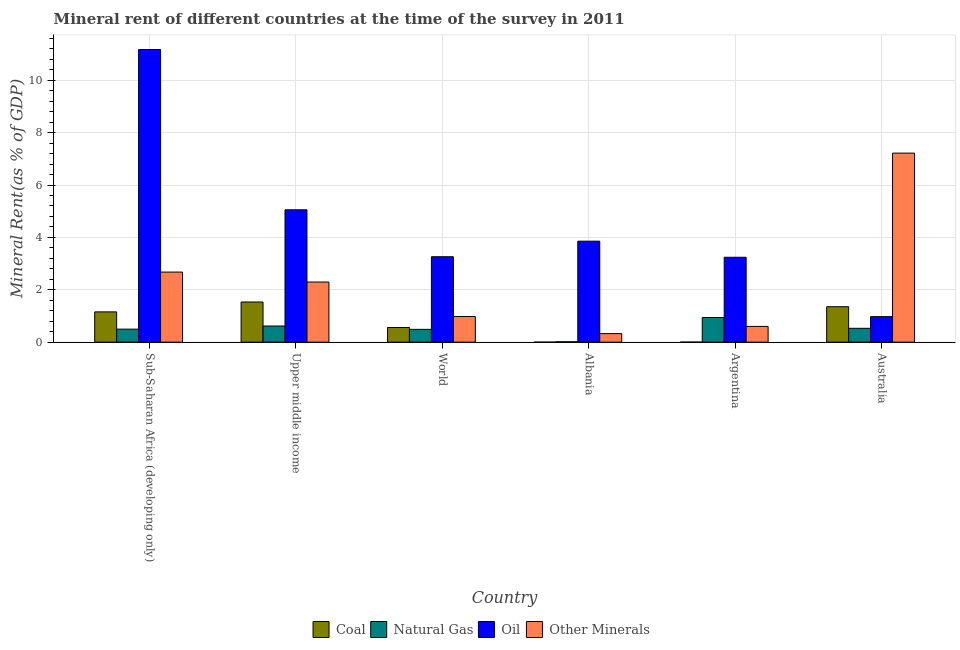How many different coloured bars are there?
Your answer should be compact. 4. Are the number of bars per tick equal to the number of legend labels?
Make the answer very short. Yes. How many bars are there on the 2nd tick from the left?
Provide a succinct answer. 4. What is the label of the 4th group of bars from the left?
Your answer should be compact. Albania. In how many cases, is the number of bars for a given country not equal to the number of legend labels?
Your answer should be compact. 0. What is the coal rent in Sub-Saharan Africa (developing only)?
Keep it short and to the point. 1.16. Across all countries, what is the maximum oil rent?
Make the answer very short. 11.17. Across all countries, what is the minimum natural gas rent?
Keep it short and to the point. 0.01. In which country was the coal rent maximum?
Offer a very short reply. Upper middle income. What is the total coal rent in the graph?
Your answer should be very brief. 4.6. What is the difference between the  rent of other minerals in Albania and that in World?
Make the answer very short. -0.65. What is the difference between the oil rent in Albania and the natural gas rent in World?
Your answer should be very brief. 3.37. What is the average oil rent per country?
Give a very brief answer. 4.59. What is the difference between the coal rent and  rent of other minerals in World?
Provide a succinct answer. -0.42. In how many countries, is the  rent of other minerals greater than 1.6 %?
Provide a succinct answer. 3. What is the ratio of the  rent of other minerals in Argentina to that in World?
Make the answer very short. 0.61. Is the difference between the natural gas rent in Australia and World greater than the difference between the oil rent in Australia and World?
Keep it short and to the point. Yes. What is the difference between the highest and the second highest natural gas rent?
Your answer should be compact. 0.33. What is the difference between the highest and the lowest  rent of other minerals?
Offer a very short reply. 6.89. In how many countries, is the coal rent greater than the average coal rent taken over all countries?
Provide a short and direct response. 3. Is the sum of the coal rent in Argentina and Upper middle income greater than the maximum oil rent across all countries?
Make the answer very short. No. What does the 1st bar from the left in Upper middle income represents?
Keep it short and to the point. Coal. What does the 3rd bar from the right in Upper middle income represents?
Your answer should be very brief. Natural Gas. Is it the case that in every country, the sum of the coal rent and natural gas rent is greater than the oil rent?
Your answer should be very brief. No. How many bars are there?
Provide a succinct answer. 24. Are all the bars in the graph horizontal?
Your answer should be compact. No. What is the difference between two consecutive major ticks on the Y-axis?
Give a very brief answer. 2. Does the graph contain any zero values?
Offer a terse response. No. Where does the legend appear in the graph?
Provide a succinct answer. Bottom center. What is the title of the graph?
Provide a short and direct response. Mineral rent of different countries at the time of the survey in 2011. Does "Industry" appear as one of the legend labels in the graph?
Your response must be concise. No. What is the label or title of the Y-axis?
Provide a short and direct response. Mineral Rent(as % of GDP). What is the Mineral Rent(as % of GDP) of Coal in Sub-Saharan Africa (developing only)?
Give a very brief answer. 1.16. What is the Mineral Rent(as % of GDP) of Natural Gas in Sub-Saharan Africa (developing only)?
Ensure brevity in your answer.  0.5. What is the Mineral Rent(as % of GDP) in Oil in Sub-Saharan Africa (developing only)?
Give a very brief answer. 11.17. What is the Mineral Rent(as % of GDP) of Other Minerals in Sub-Saharan Africa (developing only)?
Your response must be concise. 2.68. What is the Mineral Rent(as % of GDP) of Coal in Upper middle income?
Offer a very short reply. 1.53. What is the Mineral Rent(as % of GDP) in Natural Gas in Upper middle income?
Your response must be concise. 0.62. What is the Mineral Rent(as % of GDP) in Oil in Upper middle income?
Ensure brevity in your answer.  5.05. What is the Mineral Rent(as % of GDP) of Other Minerals in Upper middle income?
Keep it short and to the point. 2.3. What is the Mineral Rent(as % of GDP) of Coal in World?
Your response must be concise. 0.56. What is the Mineral Rent(as % of GDP) of Natural Gas in World?
Keep it short and to the point. 0.49. What is the Mineral Rent(as % of GDP) in Oil in World?
Provide a short and direct response. 3.26. What is the Mineral Rent(as % of GDP) in Other Minerals in World?
Keep it short and to the point. 0.98. What is the Mineral Rent(as % of GDP) of Coal in Albania?
Make the answer very short. 0. What is the Mineral Rent(as % of GDP) of Natural Gas in Albania?
Ensure brevity in your answer.  0.01. What is the Mineral Rent(as % of GDP) in Oil in Albania?
Provide a succinct answer. 3.86. What is the Mineral Rent(as % of GDP) in Other Minerals in Albania?
Give a very brief answer. 0.33. What is the Mineral Rent(as % of GDP) of Coal in Argentina?
Provide a succinct answer. 0. What is the Mineral Rent(as % of GDP) of Natural Gas in Argentina?
Offer a terse response. 0.94. What is the Mineral Rent(as % of GDP) of Oil in Argentina?
Make the answer very short. 3.24. What is the Mineral Rent(as % of GDP) in Other Minerals in Argentina?
Provide a short and direct response. 0.6. What is the Mineral Rent(as % of GDP) of Coal in Australia?
Ensure brevity in your answer.  1.35. What is the Mineral Rent(as % of GDP) in Natural Gas in Australia?
Offer a very short reply. 0.53. What is the Mineral Rent(as % of GDP) in Oil in Australia?
Provide a succinct answer. 0.97. What is the Mineral Rent(as % of GDP) of Other Minerals in Australia?
Your answer should be very brief. 7.22. Across all countries, what is the maximum Mineral Rent(as % of GDP) of Coal?
Make the answer very short. 1.53. Across all countries, what is the maximum Mineral Rent(as % of GDP) in Natural Gas?
Provide a short and direct response. 0.94. Across all countries, what is the maximum Mineral Rent(as % of GDP) in Oil?
Your answer should be very brief. 11.17. Across all countries, what is the maximum Mineral Rent(as % of GDP) of Other Minerals?
Give a very brief answer. 7.22. Across all countries, what is the minimum Mineral Rent(as % of GDP) of Coal?
Your response must be concise. 0. Across all countries, what is the minimum Mineral Rent(as % of GDP) of Natural Gas?
Make the answer very short. 0.01. Across all countries, what is the minimum Mineral Rent(as % of GDP) in Oil?
Ensure brevity in your answer.  0.97. Across all countries, what is the minimum Mineral Rent(as % of GDP) of Other Minerals?
Provide a short and direct response. 0.33. What is the total Mineral Rent(as % of GDP) in Coal in the graph?
Ensure brevity in your answer.  4.6. What is the total Mineral Rent(as % of GDP) in Natural Gas in the graph?
Your response must be concise. 3.09. What is the total Mineral Rent(as % of GDP) in Oil in the graph?
Offer a very short reply. 27.56. What is the total Mineral Rent(as % of GDP) of Other Minerals in the graph?
Provide a short and direct response. 14.09. What is the difference between the Mineral Rent(as % of GDP) of Coal in Sub-Saharan Africa (developing only) and that in Upper middle income?
Keep it short and to the point. -0.38. What is the difference between the Mineral Rent(as % of GDP) in Natural Gas in Sub-Saharan Africa (developing only) and that in Upper middle income?
Your response must be concise. -0.12. What is the difference between the Mineral Rent(as % of GDP) of Oil in Sub-Saharan Africa (developing only) and that in Upper middle income?
Provide a succinct answer. 6.12. What is the difference between the Mineral Rent(as % of GDP) of Other Minerals in Sub-Saharan Africa (developing only) and that in Upper middle income?
Provide a succinct answer. 0.38. What is the difference between the Mineral Rent(as % of GDP) of Coal in Sub-Saharan Africa (developing only) and that in World?
Your answer should be very brief. 0.6. What is the difference between the Mineral Rent(as % of GDP) in Natural Gas in Sub-Saharan Africa (developing only) and that in World?
Provide a succinct answer. 0.01. What is the difference between the Mineral Rent(as % of GDP) of Oil in Sub-Saharan Africa (developing only) and that in World?
Ensure brevity in your answer.  7.91. What is the difference between the Mineral Rent(as % of GDP) in Other Minerals in Sub-Saharan Africa (developing only) and that in World?
Provide a short and direct response. 1.7. What is the difference between the Mineral Rent(as % of GDP) of Coal in Sub-Saharan Africa (developing only) and that in Albania?
Your answer should be very brief. 1.16. What is the difference between the Mineral Rent(as % of GDP) in Natural Gas in Sub-Saharan Africa (developing only) and that in Albania?
Your response must be concise. 0.48. What is the difference between the Mineral Rent(as % of GDP) in Oil in Sub-Saharan Africa (developing only) and that in Albania?
Make the answer very short. 7.32. What is the difference between the Mineral Rent(as % of GDP) in Other Minerals in Sub-Saharan Africa (developing only) and that in Albania?
Provide a succinct answer. 2.35. What is the difference between the Mineral Rent(as % of GDP) of Coal in Sub-Saharan Africa (developing only) and that in Argentina?
Ensure brevity in your answer.  1.15. What is the difference between the Mineral Rent(as % of GDP) of Natural Gas in Sub-Saharan Africa (developing only) and that in Argentina?
Give a very brief answer. -0.44. What is the difference between the Mineral Rent(as % of GDP) in Oil in Sub-Saharan Africa (developing only) and that in Argentina?
Give a very brief answer. 7.93. What is the difference between the Mineral Rent(as % of GDP) of Other Minerals in Sub-Saharan Africa (developing only) and that in Argentina?
Provide a succinct answer. 2.07. What is the difference between the Mineral Rent(as % of GDP) in Coal in Sub-Saharan Africa (developing only) and that in Australia?
Keep it short and to the point. -0.2. What is the difference between the Mineral Rent(as % of GDP) in Natural Gas in Sub-Saharan Africa (developing only) and that in Australia?
Your answer should be compact. -0.03. What is the difference between the Mineral Rent(as % of GDP) of Oil in Sub-Saharan Africa (developing only) and that in Australia?
Provide a succinct answer. 10.2. What is the difference between the Mineral Rent(as % of GDP) in Other Minerals in Sub-Saharan Africa (developing only) and that in Australia?
Keep it short and to the point. -4.54. What is the difference between the Mineral Rent(as % of GDP) of Coal in Upper middle income and that in World?
Your response must be concise. 0.97. What is the difference between the Mineral Rent(as % of GDP) in Natural Gas in Upper middle income and that in World?
Your response must be concise. 0.13. What is the difference between the Mineral Rent(as % of GDP) in Oil in Upper middle income and that in World?
Provide a succinct answer. 1.79. What is the difference between the Mineral Rent(as % of GDP) of Other Minerals in Upper middle income and that in World?
Your answer should be compact. 1.32. What is the difference between the Mineral Rent(as % of GDP) of Coal in Upper middle income and that in Albania?
Your response must be concise. 1.53. What is the difference between the Mineral Rent(as % of GDP) in Natural Gas in Upper middle income and that in Albania?
Your answer should be compact. 0.6. What is the difference between the Mineral Rent(as % of GDP) of Oil in Upper middle income and that in Albania?
Offer a terse response. 1.2. What is the difference between the Mineral Rent(as % of GDP) in Other Minerals in Upper middle income and that in Albania?
Offer a very short reply. 1.97. What is the difference between the Mineral Rent(as % of GDP) in Coal in Upper middle income and that in Argentina?
Your answer should be very brief. 1.53. What is the difference between the Mineral Rent(as % of GDP) of Natural Gas in Upper middle income and that in Argentina?
Ensure brevity in your answer.  -0.33. What is the difference between the Mineral Rent(as % of GDP) in Oil in Upper middle income and that in Argentina?
Give a very brief answer. 1.81. What is the difference between the Mineral Rent(as % of GDP) of Other Minerals in Upper middle income and that in Argentina?
Your answer should be very brief. 1.69. What is the difference between the Mineral Rent(as % of GDP) of Coal in Upper middle income and that in Australia?
Offer a terse response. 0.18. What is the difference between the Mineral Rent(as % of GDP) of Natural Gas in Upper middle income and that in Australia?
Your answer should be compact. 0.09. What is the difference between the Mineral Rent(as % of GDP) in Oil in Upper middle income and that in Australia?
Give a very brief answer. 4.08. What is the difference between the Mineral Rent(as % of GDP) of Other Minerals in Upper middle income and that in Australia?
Offer a very short reply. -4.92. What is the difference between the Mineral Rent(as % of GDP) of Coal in World and that in Albania?
Provide a succinct answer. 0.56. What is the difference between the Mineral Rent(as % of GDP) in Natural Gas in World and that in Albania?
Keep it short and to the point. 0.47. What is the difference between the Mineral Rent(as % of GDP) of Oil in World and that in Albania?
Provide a succinct answer. -0.59. What is the difference between the Mineral Rent(as % of GDP) of Other Minerals in World and that in Albania?
Your answer should be very brief. 0.65. What is the difference between the Mineral Rent(as % of GDP) of Coal in World and that in Argentina?
Your response must be concise. 0.56. What is the difference between the Mineral Rent(as % of GDP) of Natural Gas in World and that in Argentina?
Offer a very short reply. -0.45. What is the difference between the Mineral Rent(as % of GDP) in Oil in World and that in Argentina?
Ensure brevity in your answer.  0.02. What is the difference between the Mineral Rent(as % of GDP) of Other Minerals in World and that in Argentina?
Provide a succinct answer. 0.38. What is the difference between the Mineral Rent(as % of GDP) of Coal in World and that in Australia?
Keep it short and to the point. -0.79. What is the difference between the Mineral Rent(as % of GDP) in Natural Gas in World and that in Australia?
Ensure brevity in your answer.  -0.04. What is the difference between the Mineral Rent(as % of GDP) of Oil in World and that in Australia?
Provide a short and direct response. 2.29. What is the difference between the Mineral Rent(as % of GDP) of Other Minerals in World and that in Australia?
Your answer should be compact. -6.24. What is the difference between the Mineral Rent(as % of GDP) of Coal in Albania and that in Argentina?
Provide a succinct answer. -0. What is the difference between the Mineral Rent(as % of GDP) of Natural Gas in Albania and that in Argentina?
Your answer should be compact. -0.93. What is the difference between the Mineral Rent(as % of GDP) in Oil in Albania and that in Argentina?
Provide a succinct answer. 0.62. What is the difference between the Mineral Rent(as % of GDP) in Other Minerals in Albania and that in Argentina?
Give a very brief answer. -0.27. What is the difference between the Mineral Rent(as % of GDP) in Coal in Albania and that in Australia?
Make the answer very short. -1.35. What is the difference between the Mineral Rent(as % of GDP) of Natural Gas in Albania and that in Australia?
Offer a very short reply. -0.51. What is the difference between the Mineral Rent(as % of GDP) in Oil in Albania and that in Australia?
Offer a very short reply. 2.88. What is the difference between the Mineral Rent(as % of GDP) in Other Minerals in Albania and that in Australia?
Provide a succinct answer. -6.89. What is the difference between the Mineral Rent(as % of GDP) in Coal in Argentina and that in Australia?
Give a very brief answer. -1.35. What is the difference between the Mineral Rent(as % of GDP) in Natural Gas in Argentina and that in Australia?
Make the answer very short. 0.41. What is the difference between the Mineral Rent(as % of GDP) in Oil in Argentina and that in Australia?
Provide a short and direct response. 2.27. What is the difference between the Mineral Rent(as % of GDP) of Other Minerals in Argentina and that in Australia?
Your answer should be very brief. -6.62. What is the difference between the Mineral Rent(as % of GDP) in Coal in Sub-Saharan Africa (developing only) and the Mineral Rent(as % of GDP) in Natural Gas in Upper middle income?
Give a very brief answer. 0.54. What is the difference between the Mineral Rent(as % of GDP) of Coal in Sub-Saharan Africa (developing only) and the Mineral Rent(as % of GDP) of Oil in Upper middle income?
Provide a short and direct response. -3.9. What is the difference between the Mineral Rent(as % of GDP) of Coal in Sub-Saharan Africa (developing only) and the Mineral Rent(as % of GDP) of Other Minerals in Upper middle income?
Make the answer very short. -1.14. What is the difference between the Mineral Rent(as % of GDP) in Natural Gas in Sub-Saharan Africa (developing only) and the Mineral Rent(as % of GDP) in Oil in Upper middle income?
Offer a very short reply. -4.56. What is the difference between the Mineral Rent(as % of GDP) of Natural Gas in Sub-Saharan Africa (developing only) and the Mineral Rent(as % of GDP) of Other Minerals in Upper middle income?
Your answer should be very brief. -1.8. What is the difference between the Mineral Rent(as % of GDP) of Oil in Sub-Saharan Africa (developing only) and the Mineral Rent(as % of GDP) of Other Minerals in Upper middle income?
Make the answer very short. 8.88. What is the difference between the Mineral Rent(as % of GDP) in Coal in Sub-Saharan Africa (developing only) and the Mineral Rent(as % of GDP) in Oil in World?
Give a very brief answer. -2.11. What is the difference between the Mineral Rent(as % of GDP) in Coal in Sub-Saharan Africa (developing only) and the Mineral Rent(as % of GDP) in Other Minerals in World?
Your response must be concise. 0.18. What is the difference between the Mineral Rent(as % of GDP) of Natural Gas in Sub-Saharan Africa (developing only) and the Mineral Rent(as % of GDP) of Oil in World?
Your response must be concise. -2.76. What is the difference between the Mineral Rent(as % of GDP) in Natural Gas in Sub-Saharan Africa (developing only) and the Mineral Rent(as % of GDP) in Other Minerals in World?
Provide a short and direct response. -0.48. What is the difference between the Mineral Rent(as % of GDP) of Oil in Sub-Saharan Africa (developing only) and the Mineral Rent(as % of GDP) of Other Minerals in World?
Make the answer very short. 10.2. What is the difference between the Mineral Rent(as % of GDP) of Coal in Sub-Saharan Africa (developing only) and the Mineral Rent(as % of GDP) of Natural Gas in Albania?
Make the answer very short. 1.14. What is the difference between the Mineral Rent(as % of GDP) in Coal in Sub-Saharan Africa (developing only) and the Mineral Rent(as % of GDP) in Oil in Albania?
Provide a succinct answer. -2.7. What is the difference between the Mineral Rent(as % of GDP) of Coal in Sub-Saharan Africa (developing only) and the Mineral Rent(as % of GDP) of Other Minerals in Albania?
Offer a very short reply. 0.83. What is the difference between the Mineral Rent(as % of GDP) in Natural Gas in Sub-Saharan Africa (developing only) and the Mineral Rent(as % of GDP) in Oil in Albania?
Give a very brief answer. -3.36. What is the difference between the Mineral Rent(as % of GDP) in Natural Gas in Sub-Saharan Africa (developing only) and the Mineral Rent(as % of GDP) in Other Minerals in Albania?
Give a very brief answer. 0.17. What is the difference between the Mineral Rent(as % of GDP) of Oil in Sub-Saharan Africa (developing only) and the Mineral Rent(as % of GDP) of Other Minerals in Albania?
Offer a very short reply. 10.85. What is the difference between the Mineral Rent(as % of GDP) in Coal in Sub-Saharan Africa (developing only) and the Mineral Rent(as % of GDP) in Natural Gas in Argentina?
Provide a short and direct response. 0.21. What is the difference between the Mineral Rent(as % of GDP) of Coal in Sub-Saharan Africa (developing only) and the Mineral Rent(as % of GDP) of Oil in Argentina?
Your answer should be very brief. -2.09. What is the difference between the Mineral Rent(as % of GDP) of Coal in Sub-Saharan Africa (developing only) and the Mineral Rent(as % of GDP) of Other Minerals in Argentina?
Keep it short and to the point. 0.55. What is the difference between the Mineral Rent(as % of GDP) in Natural Gas in Sub-Saharan Africa (developing only) and the Mineral Rent(as % of GDP) in Oil in Argentina?
Ensure brevity in your answer.  -2.74. What is the difference between the Mineral Rent(as % of GDP) of Natural Gas in Sub-Saharan Africa (developing only) and the Mineral Rent(as % of GDP) of Other Minerals in Argentina?
Your answer should be very brief. -0.1. What is the difference between the Mineral Rent(as % of GDP) of Oil in Sub-Saharan Africa (developing only) and the Mineral Rent(as % of GDP) of Other Minerals in Argentina?
Your response must be concise. 10.57. What is the difference between the Mineral Rent(as % of GDP) of Coal in Sub-Saharan Africa (developing only) and the Mineral Rent(as % of GDP) of Natural Gas in Australia?
Provide a short and direct response. 0.63. What is the difference between the Mineral Rent(as % of GDP) in Coal in Sub-Saharan Africa (developing only) and the Mineral Rent(as % of GDP) in Oil in Australia?
Your answer should be compact. 0.18. What is the difference between the Mineral Rent(as % of GDP) in Coal in Sub-Saharan Africa (developing only) and the Mineral Rent(as % of GDP) in Other Minerals in Australia?
Offer a terse response. -6.06. What is the difference between the Mineral Rent(as % of GDP) of Natural Gas in Sub-Saharan Africa (developing only) and the Mineral Rent(as % of GDP) of Oil in Australia?
Offer a very short reply. -0.48. What is the difference between the Mineral Rent(as % of GDP) of Natural Gas in Sub-Saharan Africa (developing only) and the Mineral Rent(as % of GDP) of Other Minerals in Australia?
Provide a succinct answer. -6.72. What is the difference between the Mineral Rent(as % of GDP) of Oil in Sub-Saharan Africa (developing only) and the Mineral Rent(as % of GDP) of Other Minerals in Australia?
Give a very brief answer. 3.96. What is the difference between the Mineral Rent(as % of GDP) in Coal in Upper middle income and the Mineral Rent(as % of GDP) in Natural Gas in World?
Your answer should be compact. 1.04. What is the difference between the Mineral Rent(as % of GDP) in Coal in Upper middle income and the Mineral Rent(as % of GDP) in Oil in World?
Your answer should be compact. -1.73. What is the difference between the Mineral Rent(as % of GDP) in Coal in Upper middle income and the Mineral Rent(as % of GDP) in Other Minerals in World?
Make the answer very short. 0.55. What is the difference between the Mineral Rent(as % of GDP) in Natural Gas in Upper middle income and the Mineral Rent(as % of GDP) in Oil in World?
Offer a terse response. -2.65. What is the difference between the Mineral Rent(as % of GDP) of Natural Gas in Upper middle income and the Mineral Rent(as % of GDP) of Other Minerals in World?
Provide a succinct answer. -0.36. What is the difference between the Mineral Rent(as % of GDP) in Oil in Upper middle income and the Mineral Rent(as % of GDP) in Other Minerals in World?
Your response must be concise. 4.08. What is the difference between the Mineral Rent(as % of GDP) in Coal in Upper middle income and the Mineral Rent(as % of GDP) in Natural Gas in Albania?
Give a very brief answer. 1.52. What is the difference between the Mineral Rent(as % of GDP) of Coal in Upper middle income and the Mineral Rent(as % of GDP) of Oil in Albania?
Keep it short and to the point. -2.32. What is the difference between the Mineral Rent(as % of GDP) of Coal in Upper middle income and the Mineral Rent(as % of GDP) of Other Minerals in Albania?
Keep it short and to the point. 1.21. What is the difference between the Mineral Rent(as % of GDP) of Natural Gas in Upper middle income and the Mineral Rent(as % of GDP) of Oil in Albania?
Offer a terse response. -3.24. What is the difference between the Mineral Rent(as % of GDP) of Natural Gas in Upper middle income and the Mineral Rent(as % of GDP) of Other Minerals in Albania?
Give a very brief answer. 0.29. What is the difference between the Mineral Rent(as % of GDP) of Oil in Upper middle income and the Mineral Rent(as % of GDP) of Other Minerals in Albania?
Make the answer very short. 4.73. What is the difference between the Mineral Rent(as % of GDP) in Coal in Upper middle income and the Mineral Rent(as % of GDP) in Natural Gas in Argentina?
Your answer should be compact. 0.59. What is the difference between the Mineral Rent(as % of GDP) in Coal in Upper middle income and the Mineral Rent(as % of GDP) in Oil in Argentina?
Provide a short and direct response. -1.71. What is the difference between the Mineral Rent(as % of GDP) in Coal in Upper middle income and the Mineral Rent(as % of GDP) in Other Minerals in Argentina?
Offer a very short reply. 0.93. What is the difference between the Mineral Rent(as % of GDP) in Natural Gas in Upper middle income and the Mineral Rent(as % of GDP) in Oil in Argentina?
Provide a succinct answer. -2.62. What is the difference between the Mineral Rent(as % of GDP) in Natural Gas in Upper middle income and the Mineral Rent(as % of GDP) in Other Minerals in Argentina?
Keep it short and to the point. 0.02. What is the difference between the Mineral Rent(as % of GDP) in Oil in Upper middle income and the Mineral Rent(as % of GDP) in Other Minerals in Argentina?
Your answer should be compact. 4.45. What is the difference between the Mineral Rent(as % of GDP) in Coal in Upper middle income and the Mineral Rent(as % of GDP) in Oil in Australia?
Your response must be concise. 0.56. What is the difference between the Mineral Rent(as % of GDP) of Coal in Upper middle income and the Mineral Rent(as % of GDP) of Other Minerals in Australia?
Ensure brevity in your answer.  -5.69. What is the difference between the Mineral Rent(as % of GDP) in Natural Gas in Upper middle income and the Mineral Rent(as % of GDP) in Oil in Australia?
Give a very brief answer. -0.36. What is the difference between the Mineral Rent(as % of GDP) of Natural Gas in Upper middle income and the Mineral Rent(as % of GDP) of Other Minerals in Australia?
Provide a succinct answer. -6.6. What is the difference between the Mineral Rent(as % of GDP) in Oil in Upper middle income and the Mineral Rent(as % of GDP) in Other Minerals in Australia?
Your answer should be compact. -2.17. What is the difference between the Mineral Rent(as % of GDP) in Coal in World and the Mineral Rent(as % of GDP) in Natural Gas in Albania?
Your answer should be compact. 0.54. What is the difference between the Mineral Rent(as % of GDP) of Coal in World and the Mineral Rent(as % of GDP) of Oil in Albania?
Give a very brief answer. -3.3. What is the difference between the Mineral Rent(as % of GDP) of Coal in World and the Mineral Rent(as % of GDP) of Other Minerals in Albania?
Give a very brief answer. 0.23. What is the difference between the Mineral Rent(as % of GDP) in Natural Gas in World and the Mineral Rent(as % of GDP) in Oil in Albania?
Provide a short and direct response. -3.37. What is the difference between the Mineral Rent(as % of GDP) in Natural Gas in World and the Mineral Rent(as % of GDP) in Other Minerals in Albania?
Ensure brevity in your answer.  0.16. What is the difference between the Mineral Rent(as % of GDP) in Oil in World and the Mineral Rent(as % of GDP) in Other Minerals in Albania?
Make the answer very short. 2.94. What is the difference between the Mineral Rent(as % of GDP) in Coal in World and the Mineral Rent(as % of GDP) in Natural Gas in Argentina?
Offer a very short reply. -0.38. What is the difference between the Mineral Rent(as % of GDP) in Coal in World and the Mineral Rent(as % of GDP) in Oil in Argentina?
Offer a terse response. -2.68. What is the difference between the Mineral Rent(as % of GDP) of Coal in World and the Mineral Rent(as % of GDP) of Other Minerals in Argentina?
Offer a terse response. -0.04. What is the difference between the Mineral Rent(as % of GDP) in Natural Gas in World and the Mineral Rent(as % of GDP) in Oil in Argentina?
Provide a short and direct response. -2.75. What is the difference between the Mineral Rent(as % of GDP) of Natural Gas in World and the Mineral Rent(as % of GDP) of Other Minerals in Argentina?
Make the answer very short. -0.11. What is the difference between the Mineral Rent(as % of GDP) in Oil in World and the Mineral Rent(as % of GDP) in Other Minerals in Argentina?
Offer a terse response. 2.66. What is the difference between the Mineral Rent(as % of GDP) of Coal in World and the Mineral Rent(as % of GDP) of Natural Gas in Australia?
Make the answer very short. 0.03. What is the difference between the Mineral Rent(as % of GDP) of Coal in World and the Mineral Rent(as % of GDP) of Oil in Australia?
Your answer should be very brief. -0.41. What is the difference between the Mineral Rent(as % of GDP) in Coal in World and the Mineral Rent(as % of GDP) in Other Minerals in Australia?
Provide a succinct answer. -6.66. What is the difference between the Mineral Rent(as % of GDP) in Natural Gas in World and the Mineral Rent(as % of GDP) in Oil in Australia?
Provide a short and direct response. -0.48. What is the difference between the Mineral Rent(as % of GDP) of Natural Gas in World and the Mineral Rent(as % of GDP) of Other Minerals in Australia?
Ensure brevity in your answer.  -6.73. What is the difference between the Mineral Rent(as % of GDP) in Oil in World and the Mineral Rent(as % of GDP) in Other Minerals in Australia?
Your response must be concise. -3.96. What is the difference between the Mineral Rent(as % of GDP) in Coal in Albania and the Mineral Rent(as % of GDP) in Natural Gas in Argentina?
Your answer should be very brief. -0.94. What is the difference between the Mineral Rent(as % of GDP) in Coal in Albania and the Mineral Rent(as % of GDP) in Oil in Argentina?
Make the answer very short. -3.24. What is the difference between the Mineral Rent(as % of GDP) in Coal in Albania and the Mineral Rent(as % of GDP) in Other Minerals in Argentina?
Keep it short and to the point. -0.6. What is the difference between the Mineral Rent(as % of GDP) of Natural Gas in Albania and the Mineral Rent(as % of GDP) of Oil in Argentina?
Make the answer very short. -3.23. What is the difference between the Mineral Rent(as % of GDP) of Natural Gas in Albania and the Mineral Rent(as % of GDP) of Other Minerals in Argentina?
Offer a very short reply. -0.59. What is the difference between the Mineral Rent(as % of GDP) in Oil in Albania and the Mineral Rent(as % of GDP) in Other Minerals in Argentina?
Keep it short and to the point. 3.26. What is the difference between the Mineral Rent(as % of GDP) of Coal in Albania and the Mineral Rent(as % of GDP) of Natural Gas in Australia?
Your answer should be compact. -0.53. What is the difference between the Mineral Rent(as % of GDP) in Coal in Albania and the Mineral Rent(as % of GDP) in Oil in Australia?
Provide a succinct answer. -0.97. What is the difference between the Mineral Rent(as % of GDP) in Coal in Albania and the Mineral Rent(as % of GDP) in Other Minerals in Australia?
Your response must be concise. -7.22. What is the difference between the Mineral Rent(as % of GDP) in Natural Gas in Albania and the Mineral Rent(as % of GDP) in Oil in Australia?
Offer a terse response. -0.96. What is the difference between the Mineral Rent(as % of GDP) in Natural Gas in Albania and the Mineral Rent(as % of GDP) in Other Minerals in Australia?
Your response must be concise. -7.2. What is the difference between the Mineral Rent(as % of GDP) in Oil in Albania and the Mineral Rent(as % of GDP) in Other Minerals in Australia?
Provide a short and direct response. -3.36. What is the difference between the Mineral Rent(as % of GDP) in Coal in Argentina and the Mineral Rent(as % of GDP) in Natural Gas in Australia?
Keep it short and to the point. -0.53. What is the difference between the Mineral Rent(as % of GDP) of Coal in Argentina and the Mineral Rent(as % of GDP) of Oil in Australia?
Your response must be concise. -0.97. What is the difference between the Mineral Rent(as % of GDP) in Coal in Argentina and the Mineral Rent(as % of GDP) in Other Minerals in Australia?
Offer a terse response. -7.22. What is the difference between the Mineral Rent(as % of GDP) in Natural Gas in Argentina and the Mineral Rent(as % of GDP) in Oil in Australia?
Give a very brief answer. -0.03. What is the difference between the Mineral Rent(as % of GDP) in Natural Gas in Argentina and the Mineral Rent(as % of GDP) in Other Minerals in Australia?
Provide a short and direct response. -6.28. What is the difference between the Mineral Rent(as % of GDP) of Oil in Argentina and the Mineral Rent(as % of GDP) of Other Minerals in Australia?
Your answer should be compact. -3.98. What is the average Mineral Rent(as % of GDP) of Coal per country?
Give a very brief answer. 0.77. What is the average Mineral Rent(as % of GDP) in Natural Gas per country?
Provide a succinct answer. 0.51. What is the average Mineral Rent(as % of GDP) in Oil per country?
Offer a very short reply. 4.59. What is the average Mineral Rent(as % of GDP) of Other Minerals per country?
Your answer should be very brief. 2.35. What is the difference between the Mineral Rent(as % of GDP) in Coal and Mineral Rent(as % of GDP) in Natural Gas in Sub-Saharan Africa (developing only)?
Your answer should be compact. 0.66. What is the difference between the Mineral Rent(as % of GDP) of Coal and Mineral Rent(as % of GDP) of Oil in Sub-Saharan Africa (developing only)?
Give a very brief answer. -10.02. What is the difference between the Mineral Rent(as % of GDP) in Coal and Mineral Rent(as % of GDP) in Other Minerals in Sub-Saharan Africa (developing only)?
Provide a short and direct response. -1.52. What is the difference between the Mineral Rent(as % of GDP) of Natural Gas and Mineral Rent(as % of GDP) of Oil in Sub-Saharan Africa (developing only)?
Make the answer very short. -10.68. What is the difference between the Mineral Rent(as % of GDP) in Natural Gas and Mineral Rent(as % of GDP) in Other Minerals in Sub-Saharan Africa (developing only)?
Your response must be concise. -2.18. What is the difference between the Mineral Rent(as % of GDP) of Oil and Mineral Rent(as % of GDP) of Other Minerals in Sub-Saharan Africa (developing only)?
Provide a succinct answer. 8.5. What is the difference between the Mineral Rent(as % of GDP) of Coal and Mineral Rent(as % of GDP) of Natural Gas in Upper middle income?
Ensure brevity in your answer.  0.92. What is the difference between the Mineral Rent(as % of GDP) in Coal and Mineral Rent(as % of GDP) in Oil in Upper middle income?
Offer a very short reply. -3.52. What is the difference between the Mineral Rent(as % of GDP) in Coal and Mineral Rent(as % of GDP) in Other Minerals in Upper middle income?
Provide a short and direct response. -0.76. What is the difference between the Mineral Rent(as % of GDP) of Natural Gas and Mineral Rent(as % of GDP) of Oil in Upper middle income?
Provide a short and direct response. -4.44. What is the difference between the Mineral Rent(as % of GDP) in Natural Gas and Mineral Rent(as % of GDP) in Other Minerals in Upper middle income?
Ensure brevity in your answer.  -1.68. What is the difference between the Mineral Rent(as % of GDP) in Oil and Mineral Rent(as % of GDP) in Other Minerals in Upper middle income?
Ensure brevity in your answer.  2.76. What is the difference between the Mineral Rent(as % of GDP) of Coal and Mineral Rent(as % of GDP) of Natural Gas in World?
Keep it short and to the point. 0.07. What is the difference between the Mineral Rent(as % of GDP) in Coal and Mineral Rent(as % of GDP) in Oil in World?
Keep it short and to the point. -2.7. What is the difference between the Mineral Rent(as % of GDP) of Coal and Mineral Rent(as % of GDP) of Other Minerals in World?
Make the answer very short. -0.42. What is the difference between the Mineral Rent(as % of GDP) in Natural Gas and Mineral Rent(as % of GDP) in Oil in World?
Offer a very short reply. -2.77. What is the difference between the Mineral Rent(as % of GDP) of Natural Gas and Mineral Rent(as % of GDP) of Other Minerals in World?
Give a very brief answer. -0.49. What is the difference between the Mineral Rent(as % of GDP) in Oil and Mineral Rent(as % of GDP) in Other Minerals in World?
Offer a terse response. 2.28. What is the difference between the Mineral Rent(as % of GDP) in Coal and Mineral Rent(as % of GDP) in Natural Gas in Albania?
Provide a short and direct response. -0.01. What is the difference between the Mineral Rent(as % of GDP) in Coal and Mineral Rent(as % of GDP) in Oil in Albania?
Provide a succinct answer. -3.86. What is the difference between the Mineral Rent(as % of GDP) in Coal and Mineral Rent(as % of GDP) in Other Minerals in Albania?
Provide a short and direct response. -0.33. What is the difference between the Mineral Rent(as % of GDP) in Natural Gas and Mineral Rent(as % of GDP) in Oil in Albania?
Offer a very short reply. -3.84. What is the difference between the Mineral Rent(as % of GDP) in Natural Gas and Mineral Rent(as % of GDP) in Other Minerals in Albania?
Provide a succinct answer. -0.31. What is the difference between the Mineral Rent(as % of GDP) of Oil and Mineral Rent(as % of GDP) of Other Minerals in Albania?
Keep it short and to the point. 3.53. What is the difference between the Mineral Rent(as % of GDP) of Coal and Mineral Rent(as % of GDP) of Natural Gas in Argentina?
Make the answer very short. -0.94. What is the difference between the Mineral Rent(as % of GDP) in Coal and Mineral Rent(as % of GDP) in Oil in Argentina?
Ensure brevity in your answer.  -3.24. What is the difference between the Mineral Rent(as % of GDP) of Coal and Mineral Rent(as % of GDP) of Other Minerals in Argentina?
Provide a short and direct response. -0.6. What is the difference between the Mineral Rent(as % of GDP) of Natural Gas and Mineral Rent(as % of GDP) of Oil in Argentina?
Keep it short and to the point. -2.3. What is the difference between the Mineral Rent(as % of GDP) in Natural Gas and Mineral Rent(as % of GDP) in Other Minerals in Argentina?
Provide a short and direct response. 0.34. What is the difference between the Mineral Rent(as % of GDP) in Oil and Mineral Rent(as % of GDP) in Other Minerals in Argentina?
Offer a very short reply. 2.64. What is the difference between the Mineral Rent(as % of GDP) in Coal and Mineral Rent(as % of GDP) in Natural Gas in Australia?
Offer a very short reply. 0.82. What is the difference between the Mineral Rent(as % of GDP) in Coal and Mineral Rent(as % of GDP) in Oil in Australia?
Offer a terse response. 0.38. What is the difference between the Mineral Rent(as % of GDP) in Coal and Mineral Rent(as % of GDP) in Other Minerals in Australia?
Offer a very short reply. -5.87. What is the difference between the Mineral Rent(as % of GDP) in Natural Gas and Mineral Rent(as % of GDP) in Oil in Australia?
Make the answer very short. -0.44. What is the difference between the Mineral Rent(as % of GDP) in Natural Gas and Mineral Rent(as % of GDP) in Other Minerals in Australia?
Offer a very short reply. -6.69. What is the difference between the Mineral Rent(as % of GDP) of Oil and Mineral Rent(as % of GDP) of Other Minerals in Australia?
Your response must be concise. -6.24. What is the ratio of the Mineral Rent(as % of GDP) of Coal in Sub-Saharan Africa (developing only) to that in Upper middle income?
Your answer should be very brief. 0.75. What is the ratio of the Mineral Rent(as % of GDP) of Natural Gas in Sub-Saharan Africa (developing only) to that in Upper middle income?
Ensure brevity in your answer.  0.81. What is the ratio of the Mineral Rent(as % of GDP) in Oil in Sub-Saharan Africa (developing only) to that in Upper middle income?
Give a very brief answer. 2.21. What is the ratio of the Mineral Rent(as % of GDP) in Other Minerals in Sub-Saharan Africa (developing only) to that in Upper middle income?
Ensure brevity in your answer.  1.17. What is the ratio of the Mineral Rent(as % of GDP) of Coal in Sub-Saharan Africa (developing only) to that in World?
Make the answer very short. 2.07. What is the ratio of the Mineral Rent(as % of GDP) in Natural Gas in Sub-Saharan Africa (developing only) to that in World?
Provide a succinct answer. 1.02. What is the ratio of the Mineral Rent(as % of GDP) of Oil in Sub-Saharan Africa (developing only) to that in World?
Give a very brief answer. 3.43. What is the ratio of the Mineral Rent(as % of GDP) in Other Minerals in Sub-Saharan Africa (developing only) to that in World?
Ensure brevity in your answer.  2.74. What is the ratio of the Mineral Rent(as % of GDP) of Coal in Sub-Saharan Africa (developing only) to that in Albania?
Give a very brief answer. 4559.54. What is the ratio of the Mineral Rent(as % of GDP) of Natural Gas in Sub-Saharan Africa (developing only) to that in Albania?
Keep it short and to the point. 33.71. What is the ratio of the Mineral Rent(as % of GDP) in Oil in Sub-Saharan Africa (developing only) to that in Albania?
Offer a very short reply. 2.9. What is the ratio of the Mineral Rent(as % of GDP) of Other Minerals in Sub-Saharan Africa (developing only) to that in Albania?
Your answer should be compact. 8.21. What is the ratio of the Mineral Rent(as % of GDP) in Coal in Sub-Saharan Africa (developing only) to that in Argentina?
Give a very brief answer. 1273.32. What is the ratio of the Mineral Rent(as % of GDP) of Natural Gas in Sub-Saharan Africa (developing only) to that in Argentina?
Keep it short and to the point. 0.53. What is the ratio of the Mineral Rent(as % of GDP) of Oil in Sub-Saharan Africa (developing only) to that in Argentina?
Make the answer very short. 3.45. What is the ratio of the Mineral Rent(as % of GDP) in Other Minerals in Sub-Saharan Africa (developing only) to that in Argentina?
Keep it short and to the point. 4.45. What is the ratio of the Mineral Rent(as % of GDP) of Coal in Sub-Saharan Africa (developing only) to that in Australia?
Ensure brevity in your answer.  0.85. What is the ratio of the Mineral Rent(as % of GDP) in Oil in Sub-Saharan Africa (developing only) to that in Australia?
Provide a succinct answer. 11.48. What is the ratio of the Mineral Rent(as % of GDP) of Other Minerals in Sub-Saharan Africa (developing only) to that in Australia?
Offer a very short reply. 0.37. What is the ratio of the Mineral Rent(as % of GDP) in Coal in Upper middle income to that in World?
Provide a short and direct response. 2.74. What is the ratio of the Mineral Rent(as % of GDP) of Natural Gas in Upper middle income to that in World?
Offer a terse response. 1.26. What is the ratio of the Mineral Rent(as % of GDP) in Oil in Upper middle income to that in World?
Make the answer very short. 1.55. What is the ratio of the Mineral Rent(as % of GDP) of Other Minerals in Upper middle income to that in World?
Your answer should be very brief. 2.35. What is the ratio of the Mineral Rent(as % of GDP) of Coal in Upper middle income to that in Albania?
Provide a succinct answer. 6047.81. What is the ratio of the Mineral Rent(as % of GDP) in Natural Gas in Upper middle income to that in Albania?
Your response must be concise. 41.76. What is the ratio of the Mineral Rent(as % of GDP) in Oil in Upper middle income to that in Albania?
Give a very brief answer. 1.31. What is the ratio of the Mineral Rent(as % of GDP) in Other Minerals in Upper middle income to that in Albania?
Provide a short and direct response. 7.04. What is the ratio of the Mineral Rent(as % of GDP) of Coal in Upper middle income to that in Argentina?
Provide a succinct answer. 1688.94. What is the ratio of the Mineral Rent(as % of GDP) in Natural Gas in Upper middle income to that in Argentina?
Give a very brief answer. 0.65. What is the ratio of the Mineral Rent(as % of GDP) of Oil in Upper middle income to that in Argentina?
Make the answer very short. 1.56. What is the ratio of the Mineral Rent(as % of GDP) of Other Minerals in Upper middle income to that in Argentina?
Provide a succinct answer. 3.82. What is the ratio of the Mineral Rent(as % of GDP) of Coal in Upper middle income to that in Australia?
Make the answer very short. 1.13. What is the ratio of the Mineral Rent(as % of GDP) in Natural Gas in Upper middle income to that in Australia?
Offer a terse response. 1.16. What is the ratio of the Mineral Rent(as % of GDP) of Oil in Upper middle income to that in Australia?
Offer a very short reply. 5.19. What is the ratio of the Mineral Rent(as % of GDP) of Other Minerals in Upper middle income to that in Australia?
Make the answer very short. 0.32. What is the ratio of the Mineral Rent(as % of GDP) in Coal in World to that in Albania?
Provide a short and direct response. 2207.93. What is the ratio of the Mineral Rent(as % of GDP) of Natural Gas in World to that in Albania?
Your response must be concise. 33.15. What is the ratio of the Mineral Rent(as % of GDP) in Oil in World to that in Albania?
Offer a very short reply. 0.85. What is the ratio of the Mineral Rent(as % of GDP) in Other Minerals in World to that in Albania?
Ensure brevity in your answer.  3. What is the ratio of the Mineral Rent(as % of GDP) of Coal in World to that in Argentina?
Keep it short and to the point. 616.6. What is the ratio of the Mineral Rent(as % of GDP) in Natural Gas in World to that in Argentina?
Your response must be concise. 0.52. What is the ratio of the Mineral Rent(as % of GDP) in Oil in World to that in Argentina?
Provide a short and direct response. 1.01. What is the ratio of the Mineral Rent(as % of GDP) of Other Minerals in World to that in Argentina?
Your answer should be very brief. 1.63. What is the ratio of the Mineral Rent(as % of GDP) of Coal in World to that in Australia?
Offer a very short reply. 0.41. What is the ratio of the Mineral Rent(as % of GDP) of Natural Gas in World to that in Australia?
Keep it short and to the point. 0.92. What is the ratio of the Mineral Rent(as % of GDP) of Oil in World to that in Australia?
Give a very brief answer. 3.35. What is the ratio of the Mineral Rent(as % of GDP) in Other Minerals in World to that in Australia?
Ensure brevity in your answer.  0.14. What is the ratio of the Mineral Rent(as % of GDP) in Coal in Albania to that in Argentina?
Make the answer very short. 0.28. What is the ratio of the Mineral Rent(as % of GDP) of Natural Gas in Albania to that in Argentina?
Offer a terse response. 0.02. What is the ratio of the Mineral Rent(as % of GDP) in Oil in Albania to that in Argentina?
Your answer should be very brief. 1.19. What is the ratio of the Mineral Rent(as % of GDP) of Other Minerals in Albania to that in Argentina?
Ensure brevity in your answer.  0.54. What is the ratio of the Mineral Rent(as % of GDP) in Coal in Albania to that in Australia?
Ensure brevity in your answer.  0. What is the ratio of the Mineral Rent(as % of GDP) in Natural Gas in Albania to that in Australia?
Provide a succinct answer. 0.03. What is the ratio of the Mineral Rent(as % of GDP) in Oil in Albania to that in Australia?
Give a very brief answer. 3.96. What is the ratio of the Mineral Rent(as % of GDP) of Other Minerals in Albania to that in Australia?
Ensure brevity in your answer.  0.05. What is the ratio of the Mineral Rent(as % of GDP) in Coal in Argentina to that in Australia?
Give a very brief answer. 0. What is the ratio of the Mineral Rent(as % of GDP) in Natural Gas in Argentina to that in Australia?
Provide a short and direct response. 1.78. What is the ratio of the Mineral Rent(as % of GDP) of Oil in Argentina to that in Australia?
Make the answer very short. 3.33. What is the ratio of the Mineral Rent(as % of GDP) of Other Minerals in Argentina to that in Australia?
Your answer should be compact. 0.08. What is the difference between the highest and the second highest Mineral Rent(as % of GDP) of Coal?
Offer a very short reply. 0.18. What is the difference between the highest and the second highest Mineral Rent(as % of GDP) in Natural Gas?
Your response must be concise. 0.33. What is the difference between the highest and the second highest Mineral Rent(as % of GDP) of Oil?
Give a very brief answer. 6.12. What is the difference between the highest and the second highest Mineral Rent(as % of GDP) in Other Minerals?
Give a very brief answer. 4.54. What is the difference between the highest and the lowest Mineral Rent(as % of GDP) of Coal?
Provide a succinct answer. 1.53. What is the difference between the highest and the lowest Mineral Rent(as % of GDP) in Natural Gas?
Your answer should be very brief. 0.93. What is the difference between the highest and the lowest Mineral Rent(as % of GDP) in Oil?
Your answer should be compact. 10.2. What is the difference between the highest and the lowest Mineral Rent(as % of GDP) of Other Minerals?
Provide a short and direct response. 6.89. 